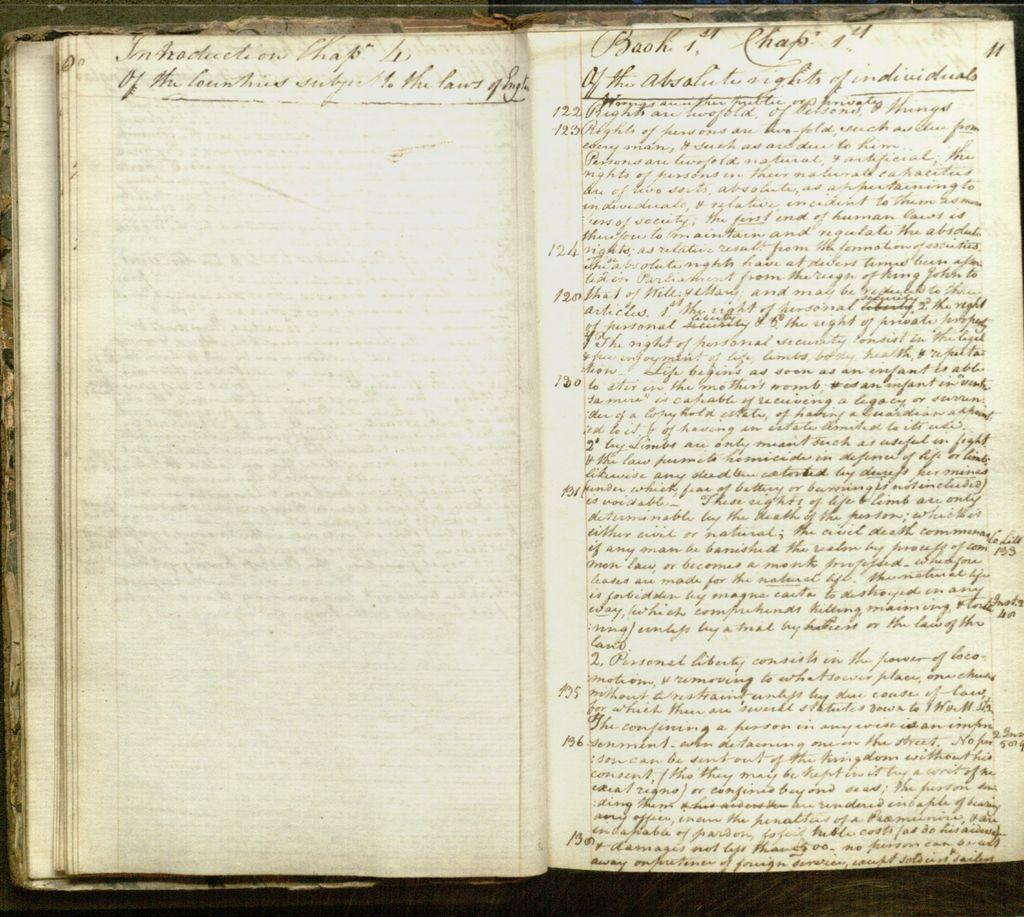<image>
Present a compact description of the photo's key features. an open book with alot of handwriting on the pages of it 